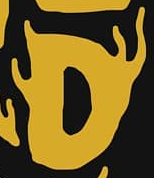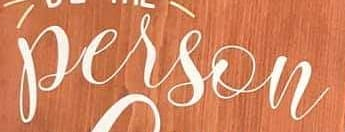What words can you see in these images in sequence, separated by a semicolon? D; person 